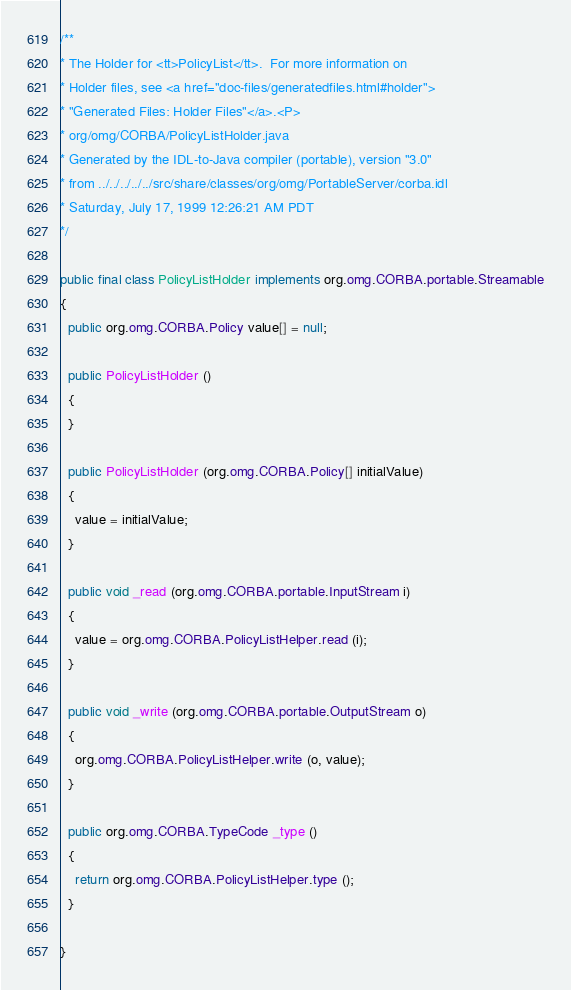Convert code to text. <code><loc_0><loc_0><loc_500><loc_500><_Java_>
/**
* The Holder for <tt>PolicyList</tt>.  For more information on
* Holder files, see <a href="doc-files/generatedfiles.html#holder">
* "Generated Files: Holder Files"</a>.<P>
* org/omg/CORBA/PolicyListHolder.java
* Generated by the IDL-to-Java compiler (portable), version "3.0"
* from ../../../../../src/share/classes/org/omg/PortableServer/corba.idl
* Saturday, July 17, 1999 12:26:21 AM PDT
*/

public final class PolicyListHolder implements org.omg.CORBA.portable.Streamable
{
  public org.omg.CORBA.Policy value[] = null;

  public PolicyListHolder ()
  {
  }

  public PolicyListHolder (org.omg.CORBA.Policy[] initialValue)
  {
    value = initialValue;
  }

  public void _read (org.omg.CORBA.portable.InputStream i)
  {
    value = org.omg.CORBA.PolicyListHelper.read (i);
  }

  public void _write (org.omg.CORBA.portable.OutputStream o)
  {
    org.omg.CORBA.PolicyListHelper.write (o, value);
  }

  public org.omg.CORBA.TypeCode _type ()
  {
    return org.omg.CORBA.PolicyListHelper.type ();
  }

}
</code> 